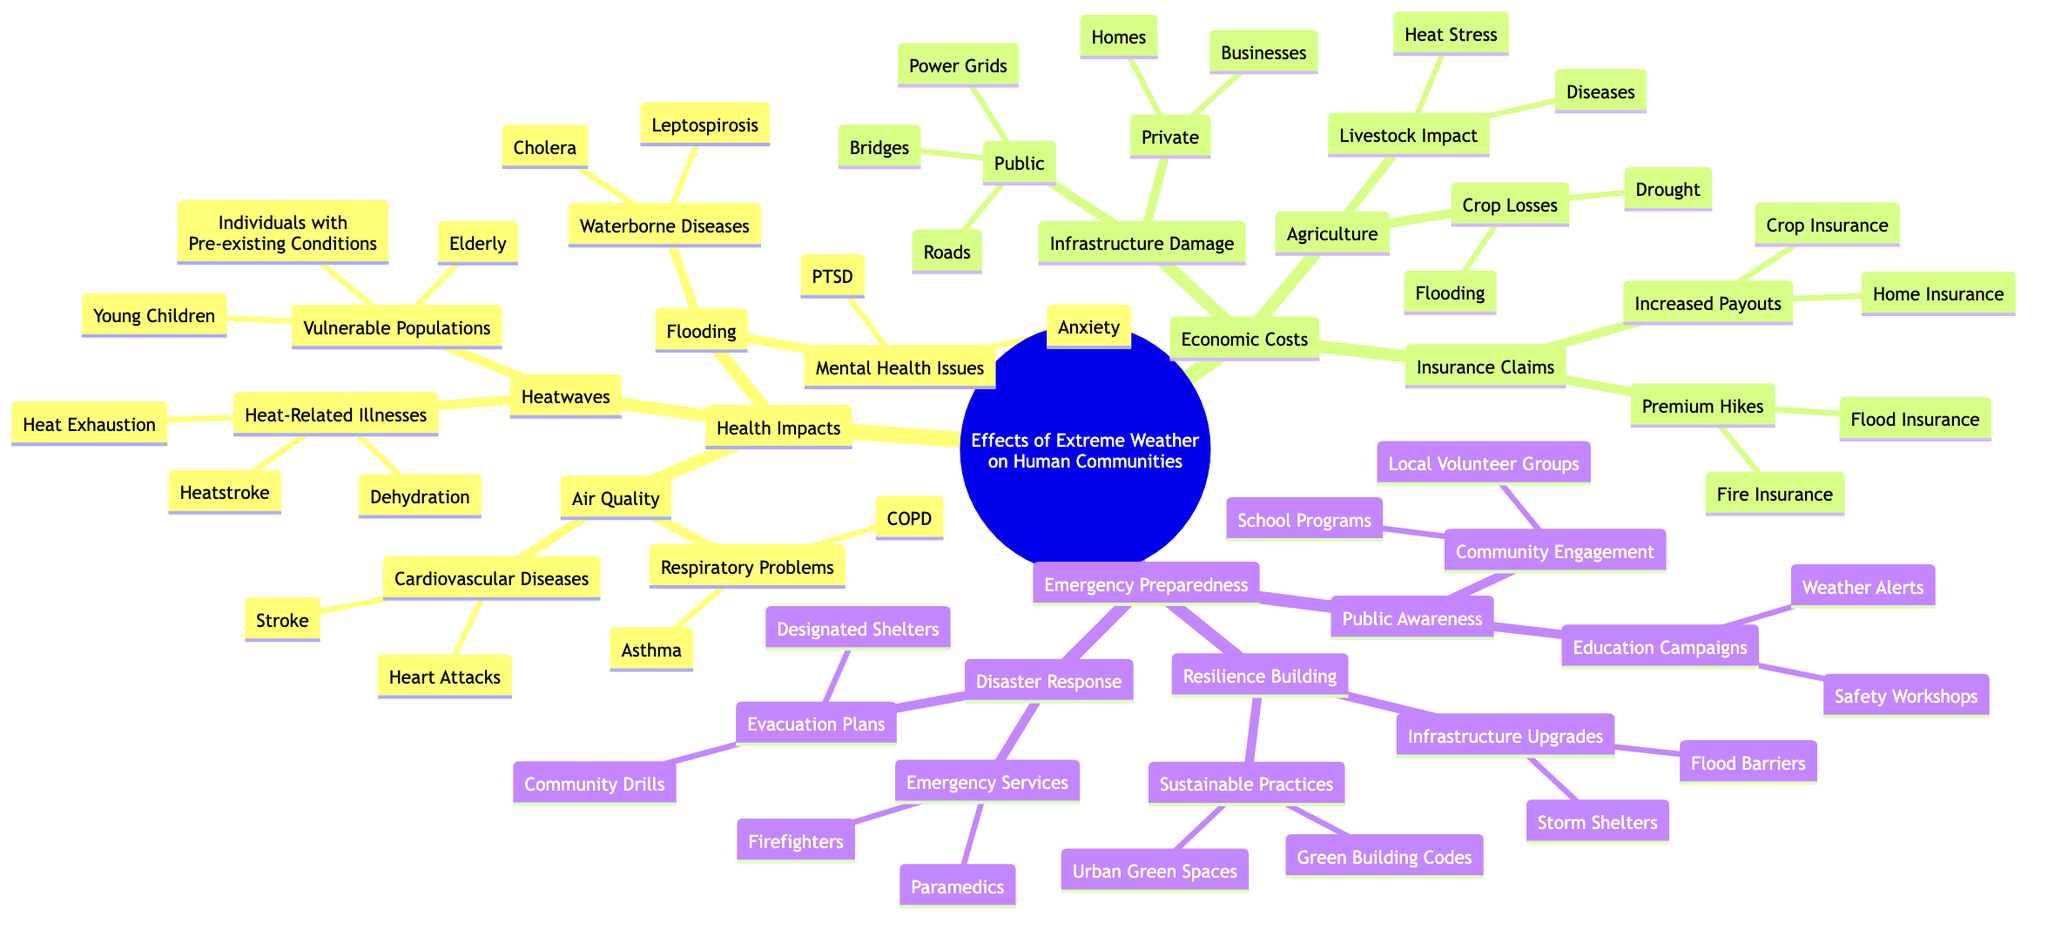What are two heat-related illnesses? The diagram lists three heat-related illnesses under the "Heatwaves" node: Heatstroke, Heat Exhaustion, and Dehydration. The question asks for two of these, so any two can be answered.
Answer: Heatstroke, Heat Exhaustion Which populations are considered vulnerable to heatwaves? Under the "Heatwaves" node, the diagram specifies three vulnerable populations: Elderly, Young Children, and Individuals with Pre-existing Conditions. The question asks for any of these groups that are vulnerable.
Answer: Elderly What are two mental health issues caused by flooding? The diagram states that flooding leads to Anxiety and PTSD under the "Mental Health Issues" node. The question asks for two of these issues, which can be directly taken from the diagram.
Answer: Anxiety, PTSD How many public infrastructure damages are listed? The "Infrastructure Damage" node under "Economic Costs" includes public infrastructure: Roads, Bridges, and Power Grids. This totals to three distinct public infrastructure types, as shown in the diagram.
Answer: 3 What type of insurance claims increase due to extreme weather? The "Insurance Claims" node outlines two types of increased payouts: Home Insurance and Crop Insurance, specifically focusing on those increased due to weather events.
Answer: Home Insurance What are two sustainable practices for resilience building? Under the "Resilience Building" section, the diagram lists two sustainable practices: Green Building Codes and Urban Green Spaces. The question can be answered with any two of these practices.
Answer: Green Building Codes, Urban Green Spaces How many waterborne diseases are associated with flooding? The "Waterborne Diseases" branch under the "Flooding" node mentions two diseases: Cholera and Leptospirosis. Thus, the number of diseases listed is two.
Answer: 2 What emergency service is mentioned in disaster response? The "Emergency Services" branch under "Disaster Response" node includes Firefighters and Paramedics. The question asks for any one of these services.
Answer: Firefighters What type of community engagement is highlighted in public awareness? The "Public Awareness" node includes "Community Engagement," which mentions Local Volunteer Groups and School Programs. Therefore, the question can be answered with either type.
Answer: Local Volunteer Groups 